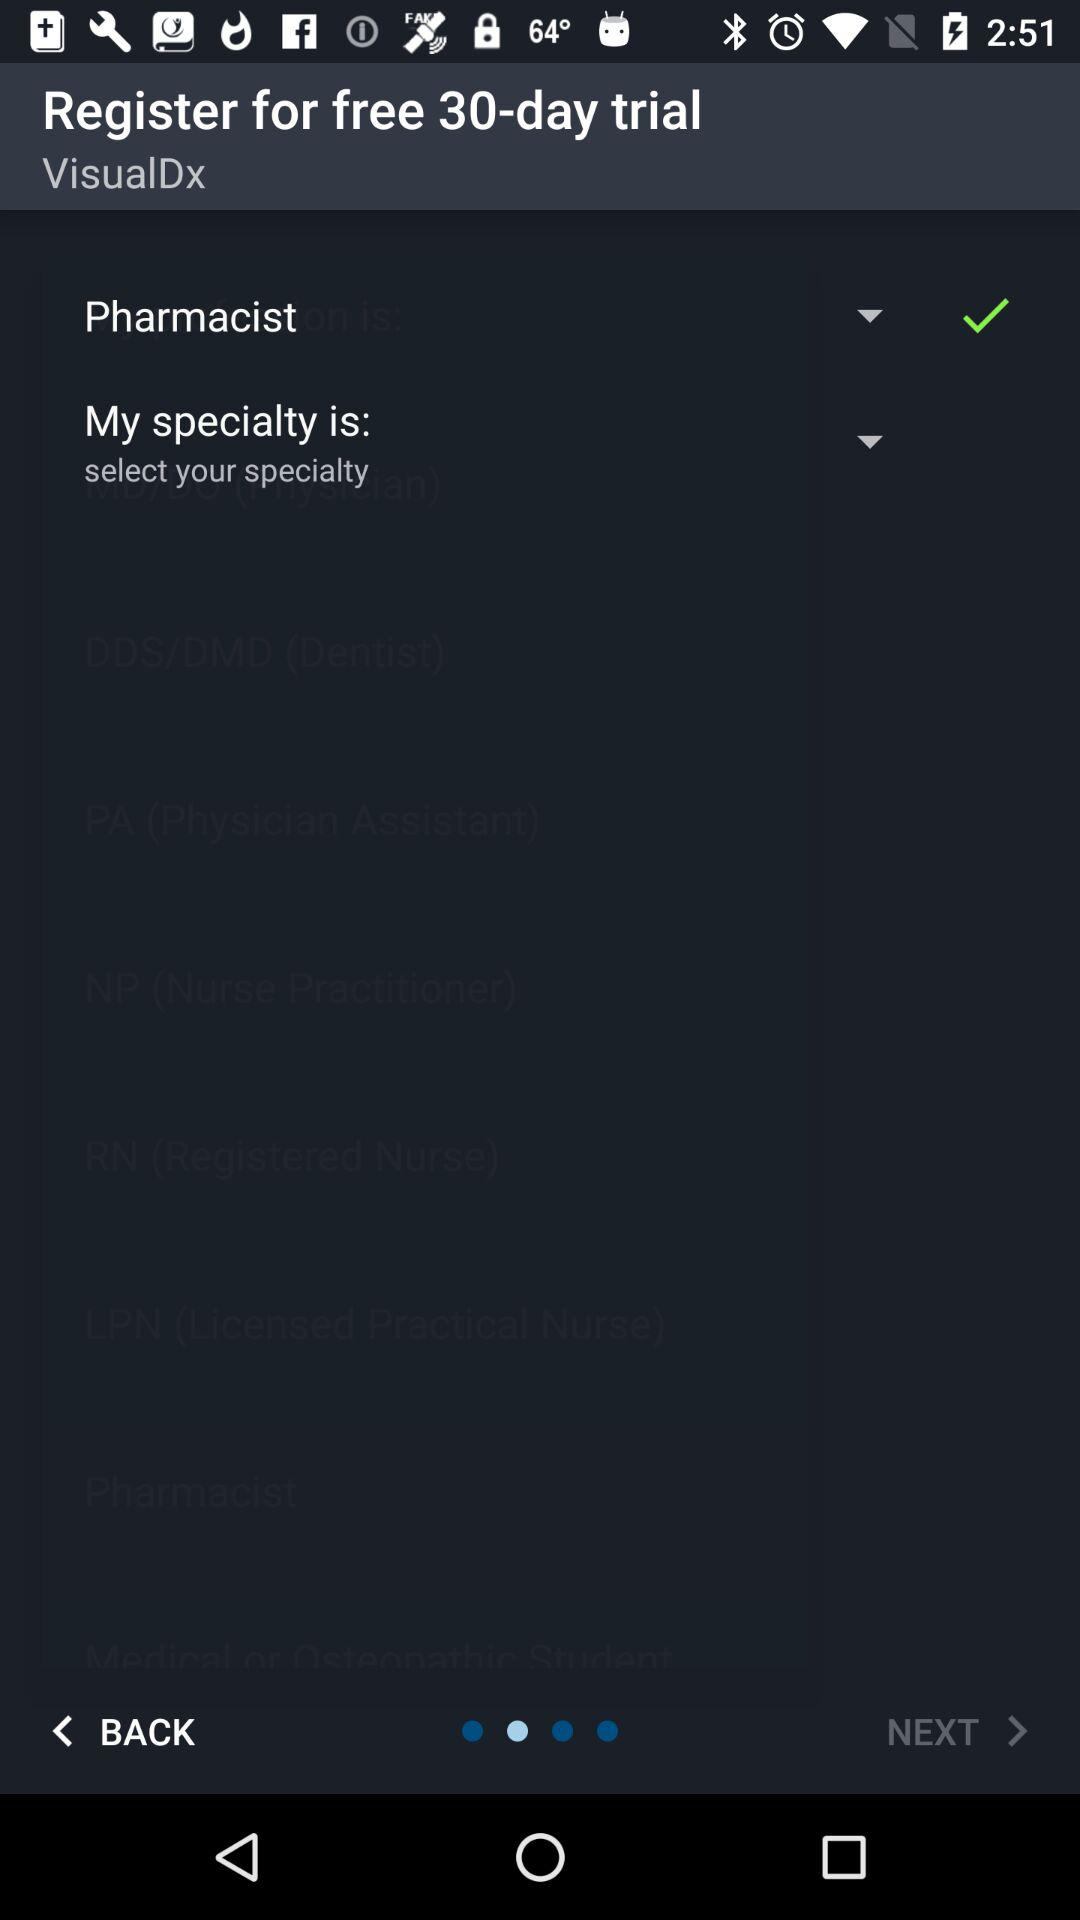What is the status of pharmacist? The status is on. 